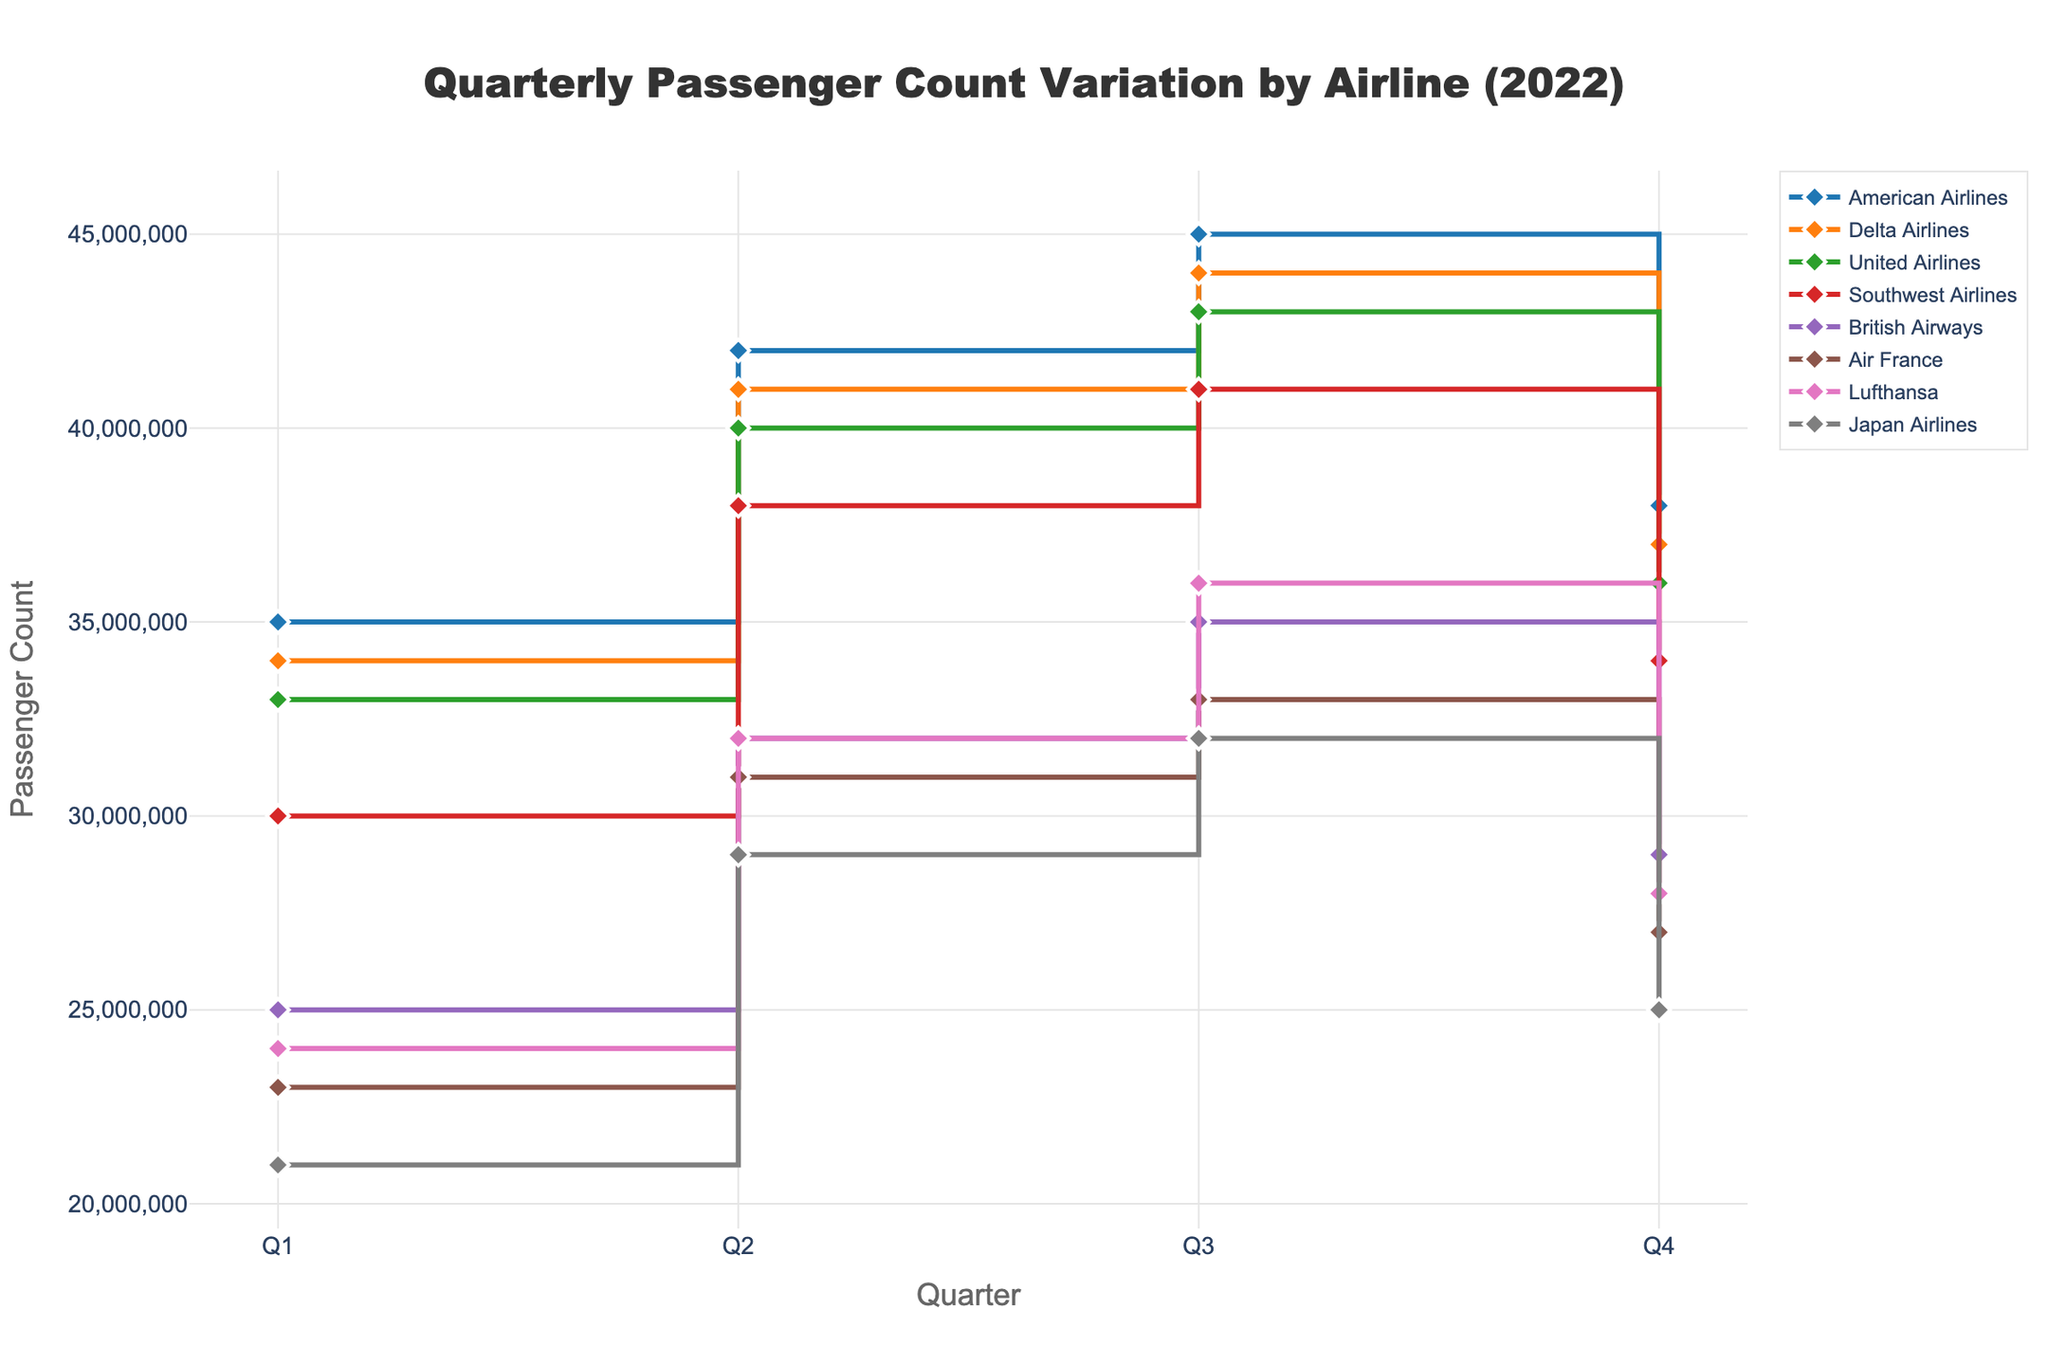What's the title of the figure? The title is prominently displayed at the top center of the figure. It reads, "Quarterly Passenger Count Variation by Airline (2022)."
Answer: Quarterly Passenger Count Variation by Airline (2022) Which airline had the highest passenger count in Q3 of 2022? By examining the stair plot for Q3, the lines representing each airline's passenger count clearly show that American Airlines is at the top with 45,000,000 passengers.
Answer: American Airlines What is the difference in the passenger count between Q1 and Q4 for Delta Airlines? To find this, we look at the data points for Delta Airlines in Q1 and Q4. The passenger count in Q1 is 34,000,000 and in Q4 it is 37,000,000. The difference is 34,000,000 - 37,000,000, which equals -3,000,000.
Answer: -3,000,000 Which airline had the least passenger count in Q2 of 2022? By checking the Q2 values for all airlines, Japan Airlines has the lowest passenger count at 29,000,000.
Answer: Japan Airlines Compare the passenger count for Air France and British Airways in Q4. Which airline has more passengers and by how much? In Q4, Air France has a passenger count of 27,000,000, while British Airways has 29,000,000. Subtracting the two values gives 29,000,000 - 27,000,000 = 2,000,000. British Airways has 2,000,000 more passengers than Air France in Q4.
Answer: British Airways by 2,000,000 What is the average passenger count for Lufthansa across all quarters in 2022? Summing Lufthansa's passenger counts for each quarter: 24,000,000 + 32,000,000 + 36,000,000 + 28,000,000 = 120,000,000. There are 4 quarters, so the average is 120,000,000 / 4 = 30,000,000.
Answer: 30,000,000 How did the passenger count for Southwest Airlines change from Q2 to Q3? Looking at the Q2 and Q3 data points for Southwest Airlines, the numbers are 38,000,000 and 41,000,000, respectively. The change is 41,000,000 - 38,000,000 = 3,000,000.
Answer: Increased by 3,000,000 Which quarters show the highest and lowest passenger counts for United Airlines in 2022? By examining the plot, United Airlines' highest passenger count is in Q3 at 43,000,000, and the lowest is in Q1 at 33,000,000.
Answer: Highest: Q3, Lowest: Q1 